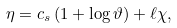<formula> <loc_0><loc_0><loc_500><loc_500>\eta = c _ { s } \left ( 1 + \log \vartheta \right ) + \ell \chi ,</formula> 